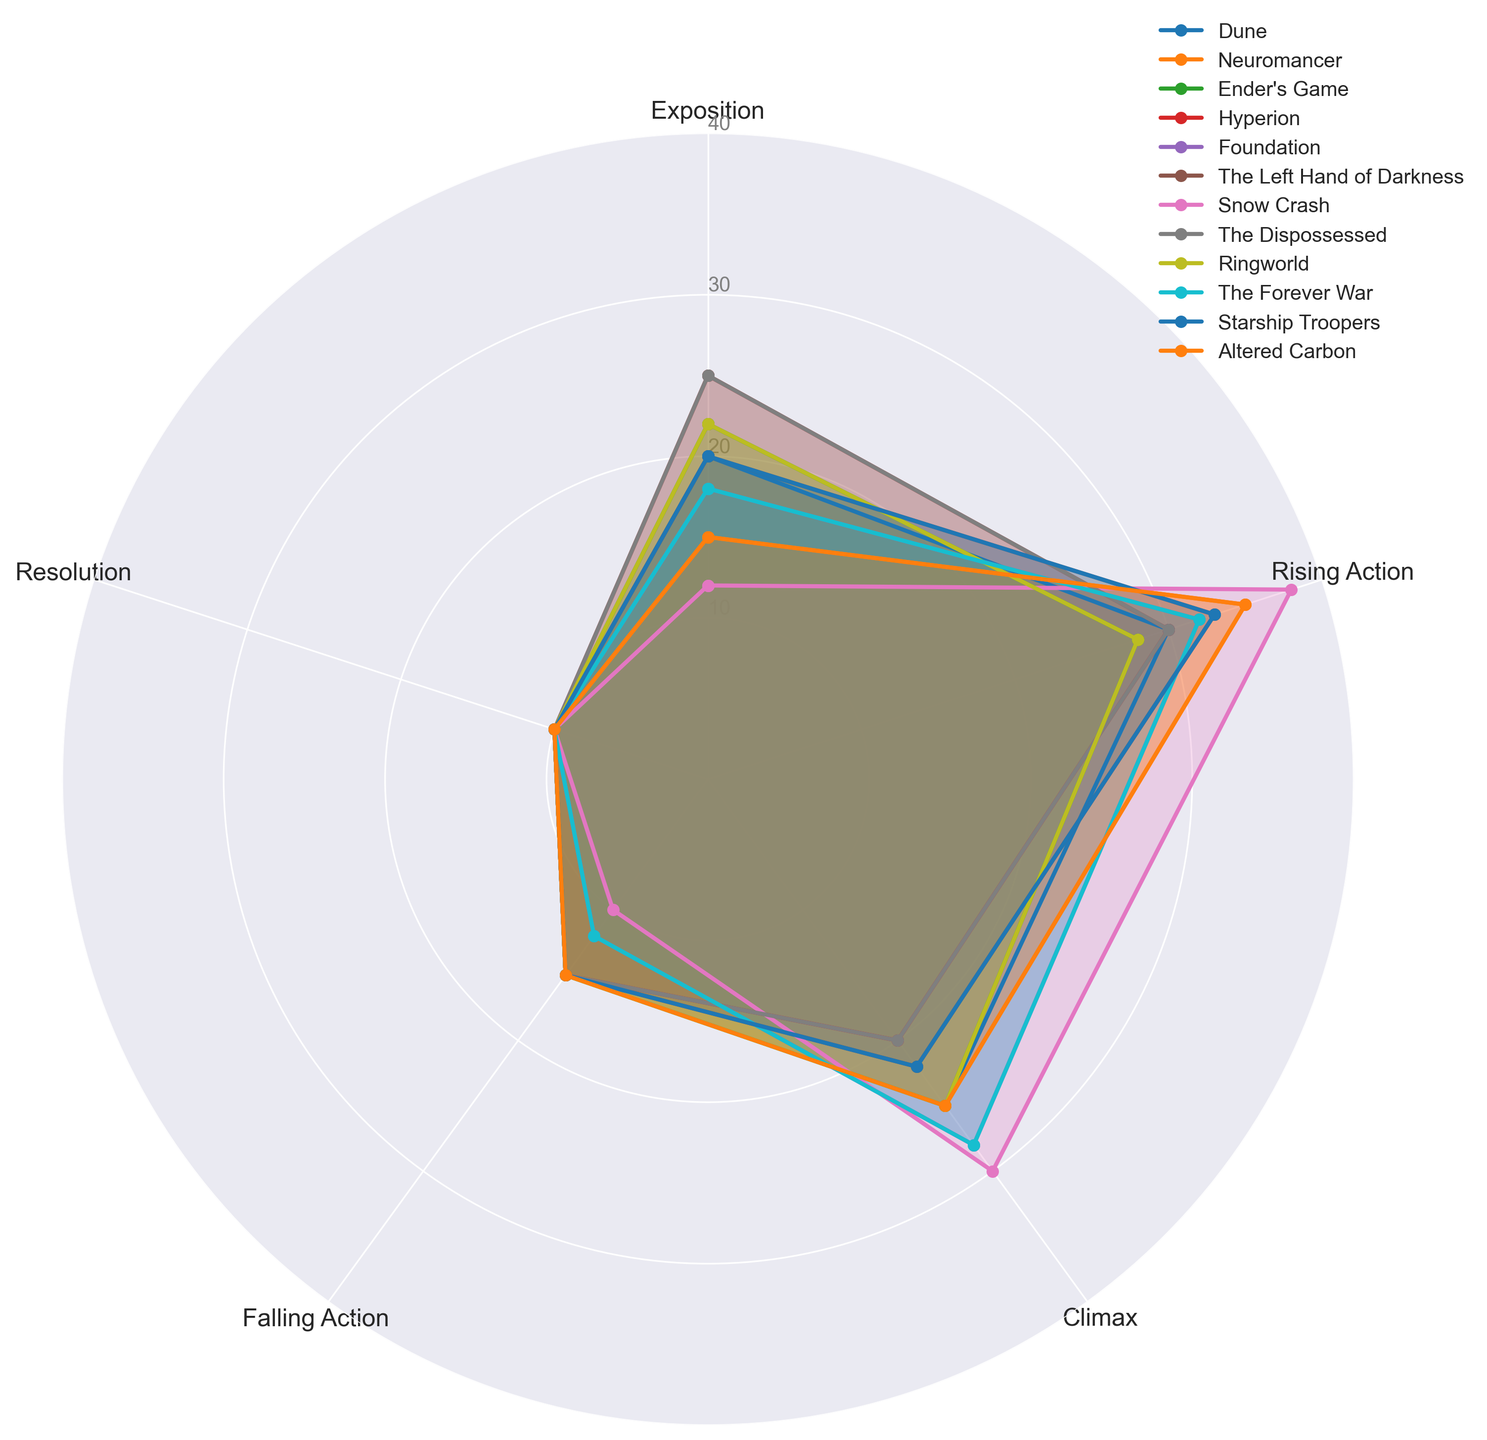What's the novel with the highest value in Rising Action? By visually inspecting the radar chart, identify which novel's radar plot extends the furthest in the segment labeled 'Rising Action'. The novel Snow Crash shows the highest value in this segment.
Answer: Snow Crash Which novel has the highest Exposition value? Examine the radar chart and find the radar plot that extends furthest from the center in the 'Exposition' segment. The novel Hyperion exhibits the highest value in Exposition.
Answer: Hyperion Between Hyperion and The Dispossessed, which novel has a lower Climax value? Look at the radar plots for both Hyperion and The Dispossessed in the 'Climax' segment. Hyperion has a lower maximum extension in this part of the chart.
Answer: Hyperion What is the sum of Exposition and Resolution values for Dune? Locate Dune in the radar chart and identify the values for 'Exposition' and 'Resolution'. Dune has Exposition of 20 and Resolution of 10. Adding these gives 20 + 10 = 30.
Answer: 30 Which novel has the most balanced distribution across all narrative elements? Look for a novel whose radar plot forms the most regular pentagon, indicative of equal values across all narrative elements. Ender's Game shows the most balanced distribution with 22, 28, 25, 15, 10 in its elements.
Answer: Ender's Game Are there any novels with equal values for Falling Action and Resolution? Inspect each radar plot and find any novel where the 'Falling Action' and 'Resolution' segments reach the same distance from the center. All novels have Falling Action and Resolution values of 15 and 10 respectively, except for Foundation and The Forever War, which both have 12 and 10 respectively. Hence, no novels have equal values for these segments.
Answer: No Which novel shows a higher value for Climax compared to Exposition? Check the 'Climax' and 'Exposition' segments for each novel. Snow Crash displays a higher value for Climax (30) than Exposition (12).
Answer: Snow Crash What is the mean value of Rising Action and Climax for Neuromancer? Identify Neuromancer's values for 'Rising Action' and 'Climax'. They are 35 and 25 respectively. Calculate the mean: (35 + 25) / 2 = 30.
Answer: 30 How many novels have a Falling Action value of 15? Identify the 'Falling Action' segment for each novel and count how many radar plots extend to 15 in this segment. Eight novels (Dune, Neuromancer, Ender's Game, Hyperion, The Left Hand of Darkness, Starship Troopers, Altered Carbon, and The Dispossessed) have a value of 15 for Falling Action.
Answer: 8 Which novel has the lowest value in Exposition and how does it compare to Snow Crash? Find the novel with the shortest extension in the 'Exposition' segment. Both Snow Crash and Altered Carbon have the lowest value of 12 for Exposition. Compare them and you will see they share this lowest value.
Answer: Snow Crash and Altered Carbon 